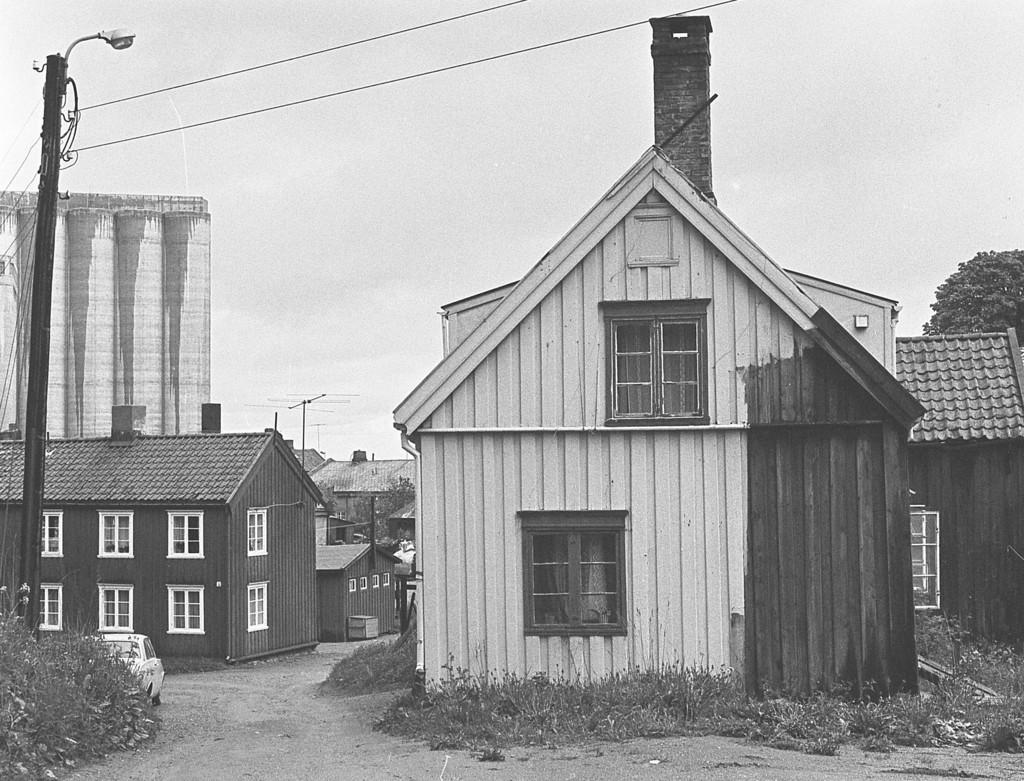Can you describe this image briefly? In this picture I can see the buildings, shed and house. In the bottom left corner there is a white color car which is parked near to the electric pole. On the pole I can see the electric wires and street light. At the top I can see the sky and clouds. At the bottom I can see the grass. On the left I can see the tree. In the center I can see the antenna on the roof of the building. 